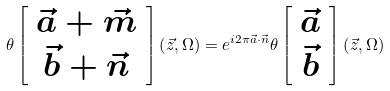Convert formula to latex. <formula><loc_0><loc_0><loc_500><loc_500>\theta \left [ \begin{array} { c } { \vec { a } } + { \vec { m } } \\ { \vec { b } } + { \vec { n } } \end{array} \right ] \left ( { \vec { z } } , \Omega \right ) = e ^ { i 2 \pi { \vec { a } } \cdot { \vec { n } } } \theta \left [ \begin{array} { c } { \vec { a } } \\ { \vec { b } } \end{array} \right ] \left ( { \vec { z } } , \Omega \right )</formula> 